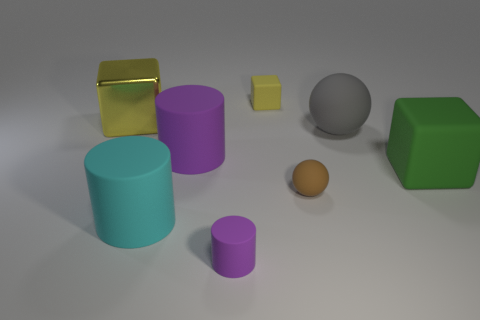Does the large cyan cylinder have the same material as the big yellow object? no 